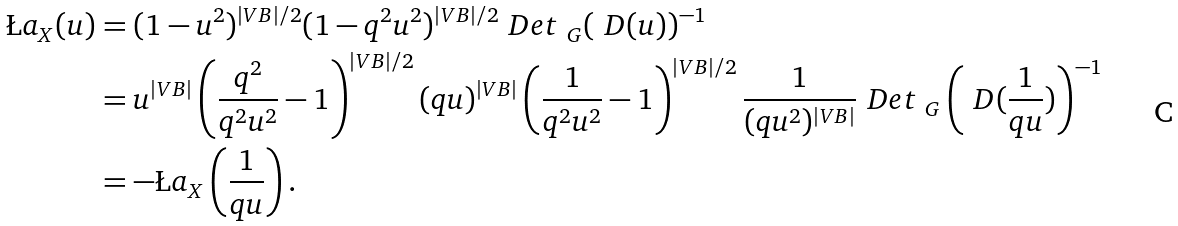Convert formula to latex. <formula><loc_0><loc_0><loc_500><loc_500>\L a _ { X } ( u ) & = ( 1 - u ^ { 2 } ) ^ { | V B | / 2 } ( 1 - q ^ { 2 } u ^ { 2 } ) ^ { | V B | / 2 } \ D e t _ { \ G } ( \ D ( u ) ) ^ { - 1 } \\ & = u ^ { | V B | } \left ( \frac { q ^ { 2 } } { q ^ { 2 } u ^ { 2 } } - 1 \right ) ^ { | V B | / 2 } ( q u ) ^ { | V B | } \left ( \frac { 1 } { q ^ { 2 } u ^ { 2 } } - 1 \right ) ^ { | V B | / 2 } \frac { 1 } { ( q u ^ { 2 } ) ^ { | V B | } } \ D e t _ { \ G } \left ( \ D ( \frac { 1 } { q u } ) \right ) ^ { - 1 } \\ & = - \L a _ { X } \left ( \frac { 1 } { q u } \right ) .</formula> 